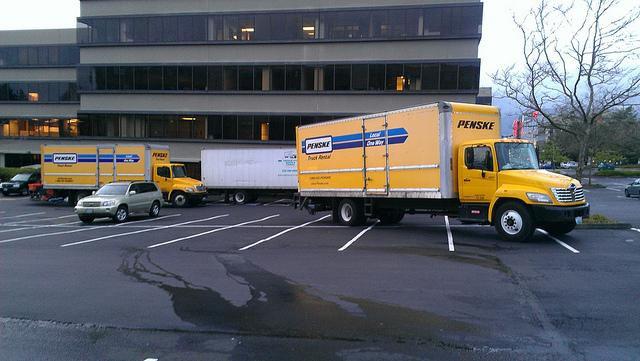What season was the photo taken?
Answer briefly. Fall. Is the truck in front parked correctly?
Write a very short answer. No. What kind of parking lot is this?
Quick response, please. Business. What company logo is the yellow truck?
Answer briefly. Penske. 